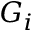Convert formula to latex. <formula><loc_0><loc_0><loc_500><loc_500>G _ { i }</formula> 